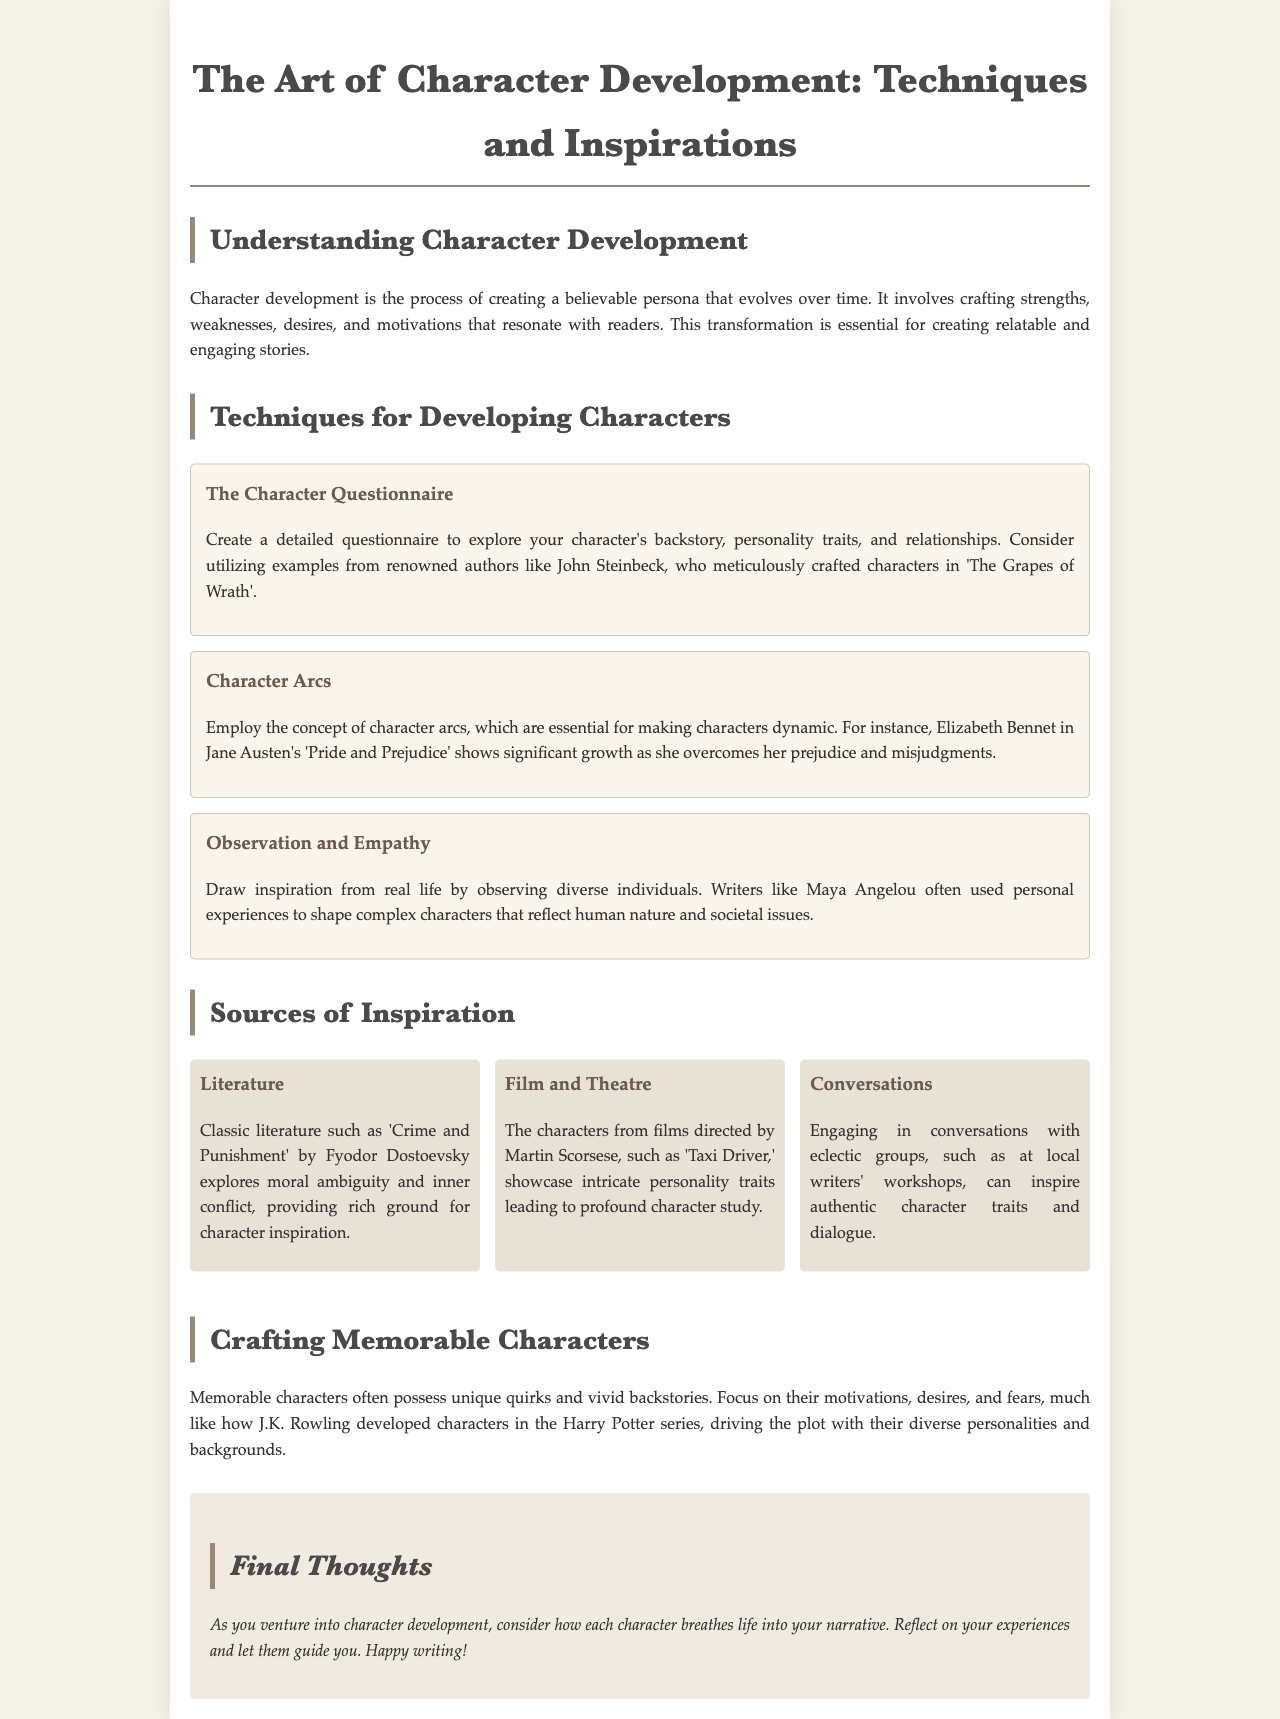What is the title of the brochure? The title is presented at the top of the document and summarizes the main theme, which is about character development in writing.
Answer: The Art of Character Development: Techniques and Inspirations Who is mentioned as an author that used character questionnaires? The document provides an example of an author whose work illustrates the concept of character questionnaires effectively.
Answer: John Steinbeck What character is used as an example of character arcs? The document cites a well-known character to show the significance of character arcs and their development throughout the story.
Answer: Elizabeth Bennet Which technique encourages drawing from real-life experiences? The document lists various methods for character development and mentions a specific approach that focuses on personal observations.
Answer: Observation and Empathy What is one source of inspiration for character development mentioned? The brochure outlines several sources of inspiration that writers can explore for creating characters, highlighting different mediums.
Answer: Literature What type of characters does J.K. Rowling develop? The document describes a well-regarded author known for crafting characters who contribute to the narrative in specific ways.
Answer: Memorable characters Which film director is cited for showcasing intricate personality traits in characters? The brochure mentions a prominent director whose works serve as examples for character study.
Answer: Martin Scorsese What should you focus on to craft memorable characters? The document gives guidance on what aspects are crucial for creating characters that leave a lasting impression.
Answer: Unique quirks and vivid backstories 